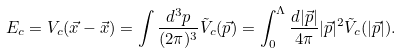Convert formula to latex. <formula><loc_0><loc_0><loc_500><loc_500>E _ { c } = V _ { c } ( \vec { x } - \vec { x } ) = \int \frac { d ^ { 3 } p } { ( 2 \pi ) ^ { 3 } } \tilde { V } _ { c } ( \vec { p } ) = \int _ { 0 } ^ { \Lambda } \frac { d | \vec { p } | } { 4 \pi } | \vec { p } | ^ { 2 } \tilde { V } _ { c } ( | \vec { p } | ) .</formula> 